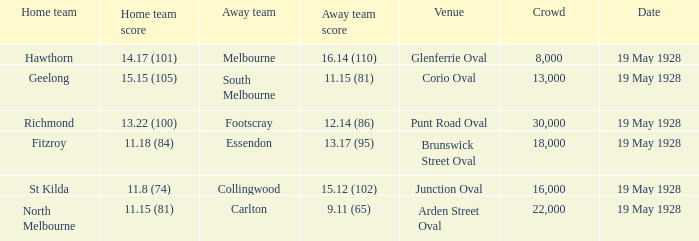What was the listed crowd at junction oval? 16000.0. 